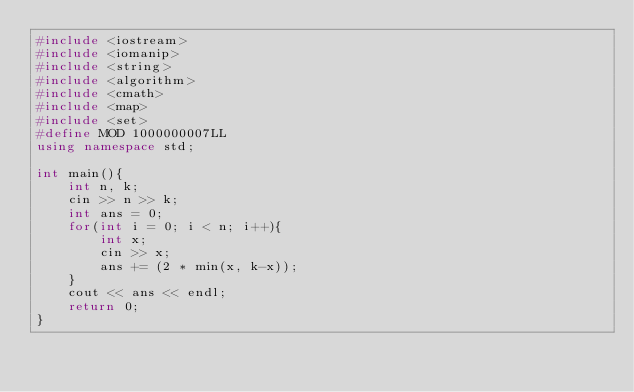<code> <loc_0><loc_0><loc_500><loc_500><_C++_>#include <iostream>
#include <iomanip>
#include <string>
#include <algorithm>
#include <cmath>
#include <map>
#include <set>
#define MOD 1000000007LL
using namespace std;

int main(){
	int n, k;
    cin >> n >> k;
	int ans = 0;
	for(int i = 0; i < n; i++){
		int x;
		cin >> x;
		ans += (2 * min(x, k-x));
	}
	cout << ans << endl;
	return 0;
}</code> 